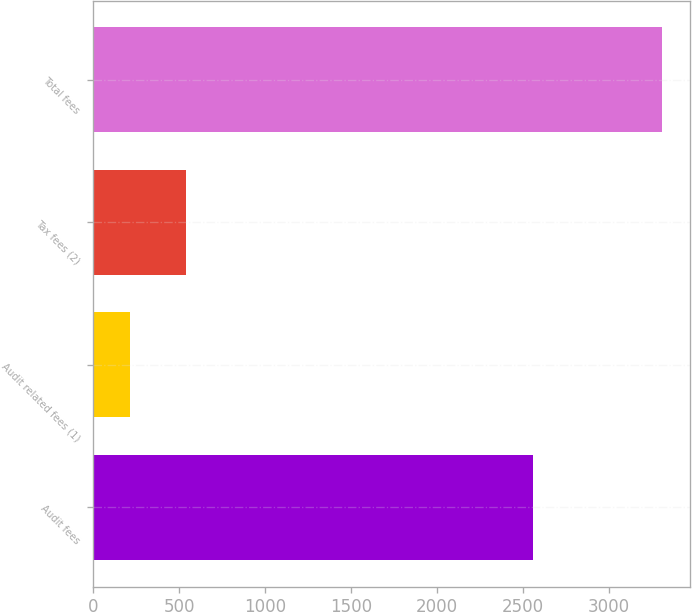Convert chart to OTSL. <chart><loc_0><loc_0><loc_500><loc_500><bar_chart><fcel>Audit fees<fcel>Audit related fees (1)<fcel>Tax fees (2)<fcel>Total fees<nl><fcel>2558<fcel>215<fcel>537<fcel>3310<nl></chart> 